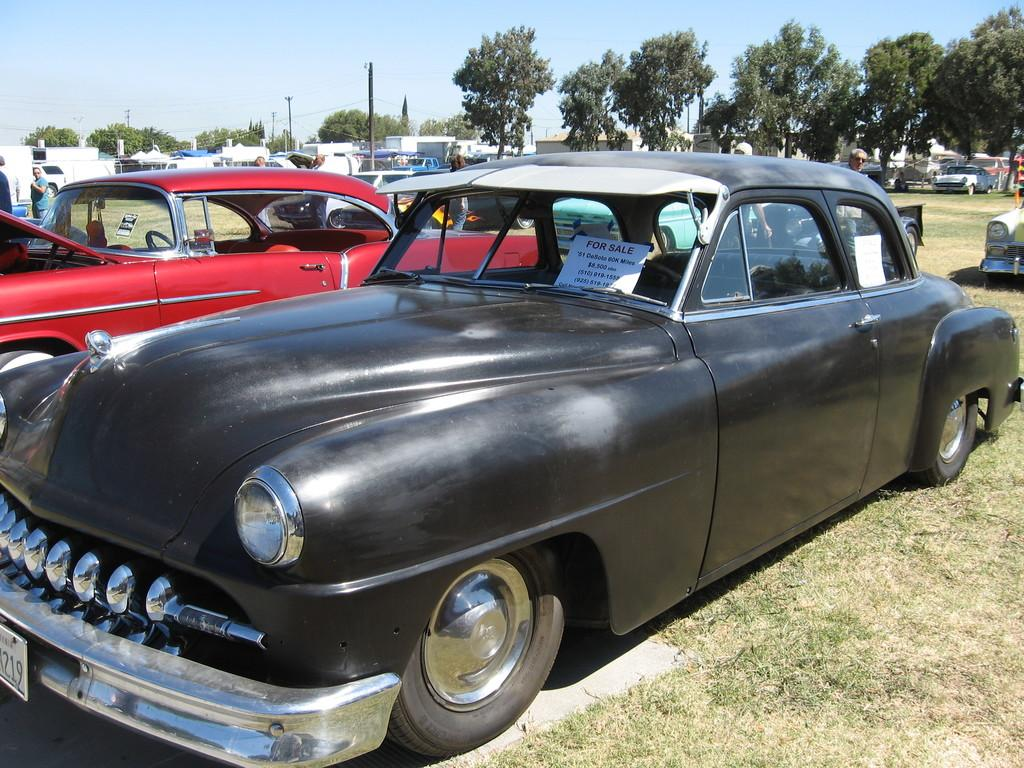What type of vehicles can be seen in the image? There are cars in the image. What is visible in the background of the image? There is a sky visible in the image. What type of vegetation is present at the top of the image? There are trees at the top of the image. Can you tell me how many sinks are visible in the image? There are no sinks present in the image. What type of educational institution can be seen in the image? There is no educational institution present in the image. 